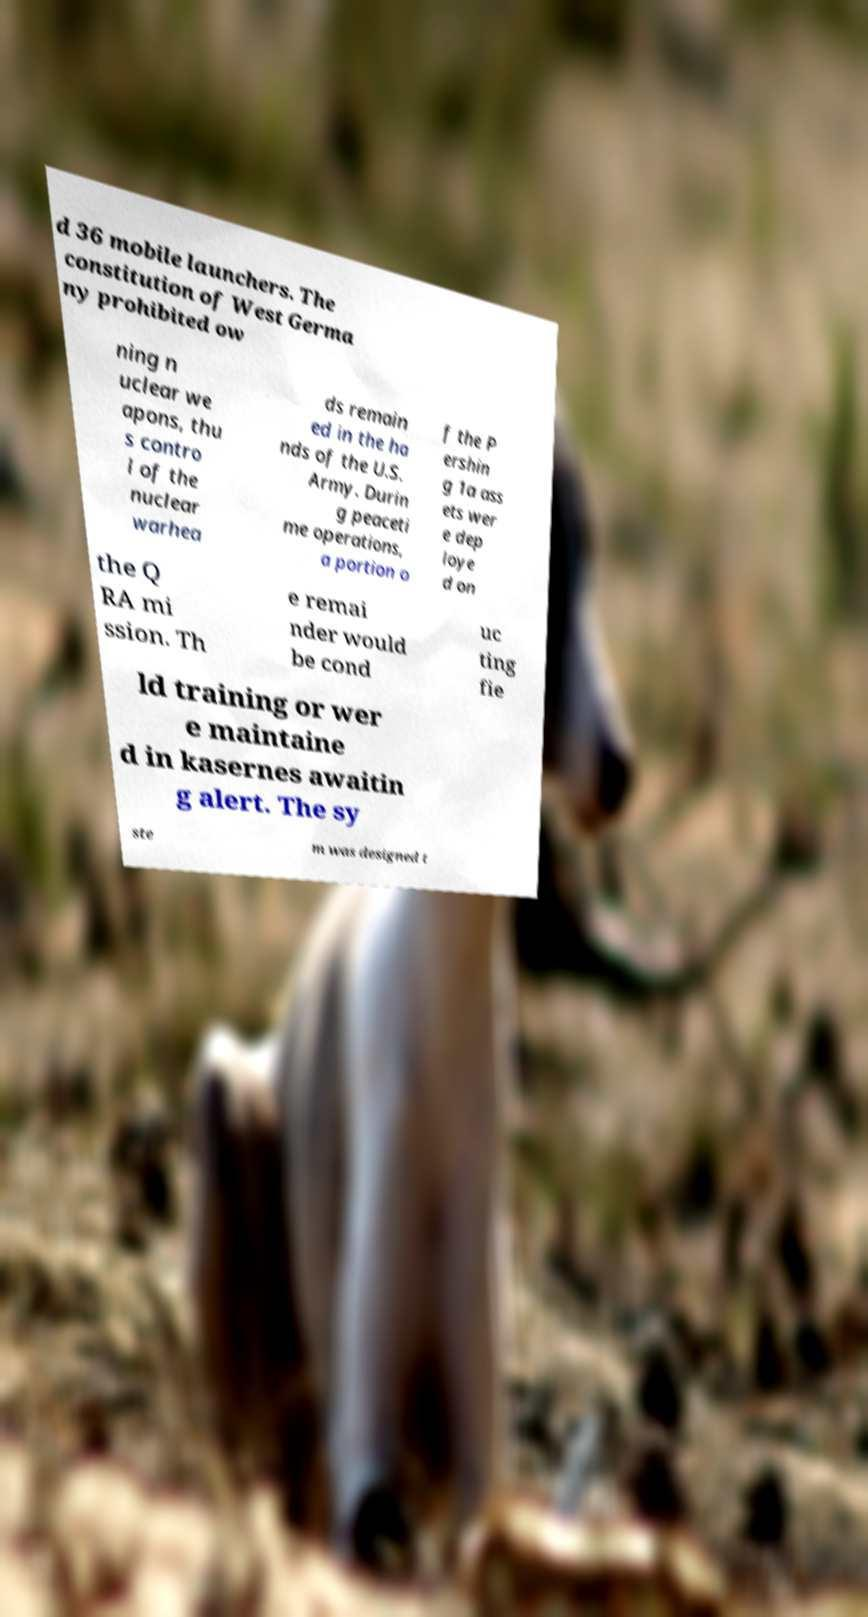For documentation purposes, I need the text within this image transcribed. Could you provide that? d 36 mobile launchers. The constitution of West Germa ny prohibited ow ning n uclear we apons, thu s contro l of the nuclear warhea ds remain ed in the ha nds of the U.S. Army. Durin g peaceti me operations, a portion o f the P ershin g 1a ass ets wer e dep loye d on the Q RA mi ssion. Th e remai nder would be cond uc ting fie ld training or wer e maintaine d in kasernes awaitin g alert. The sy ste m was designed t 